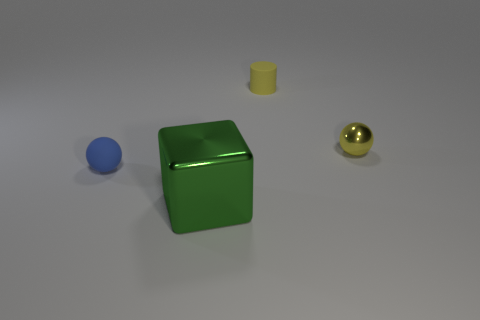The sphere that is the same color as the cylinder is what size?
Offer a very short reply. Small. What number of cylinders are green things or yellow objects?
Make the answer very short. 1. There is a metallic object that is left of the ball behind the sphere that is to the left of the yellow metal sphere; what shape is it?
Give a very brief answer. Cube. The thing that is the same color as the metal ball is what shape?
Offer a terse response. Cylinder. What number of yellow metal objects have the same size as the blue sphere?
Offer a very short reply. 1. There is a small matte object in front of the small yellow sphere; are there any matte objects that are to the left of it?
Your answer should be very brief. No. How many objects are green spheres or green objects?
Ensure brevity in your answer.  1. There is a rubber object that is behind the tiny sphere in front of the tiny ball that is on the right side of the tiny rubber sphere; what is its color?
Offer a terse response. Yellow. Is there any other thing that is the same color as the large metal thing?
Your answer should be compact. No. Do the cylinder and the yellow metal ball have the same size?
Offer a terse response. Yes. 